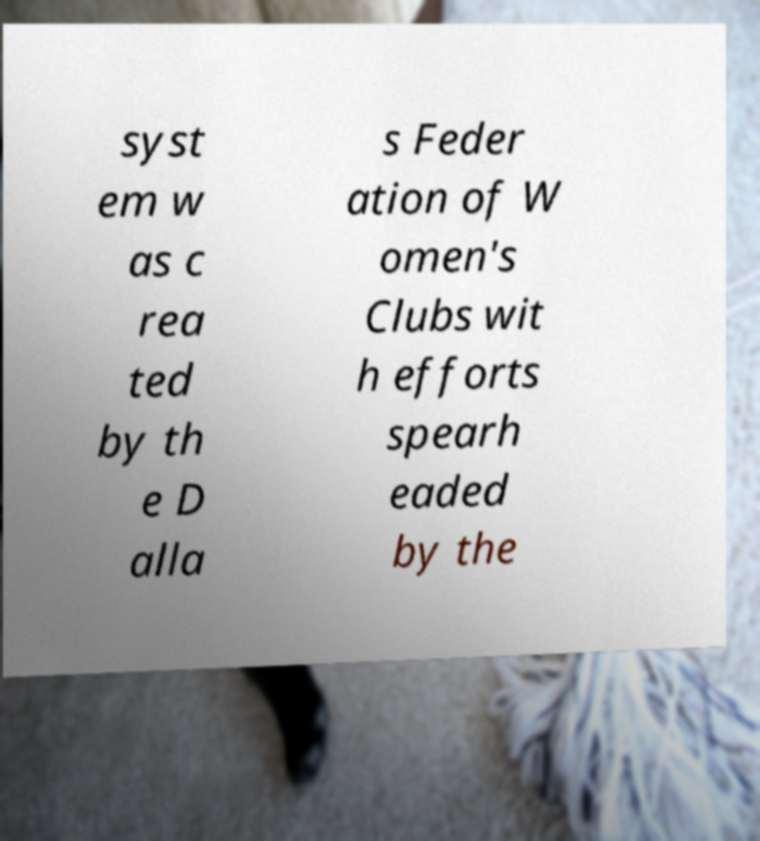I need the written content from this picture converted into text. Can you do that? syst em w as c rea ted by th e D alla s Feder ation of W omen's Clubs wit h efforts spearh eaded by the 